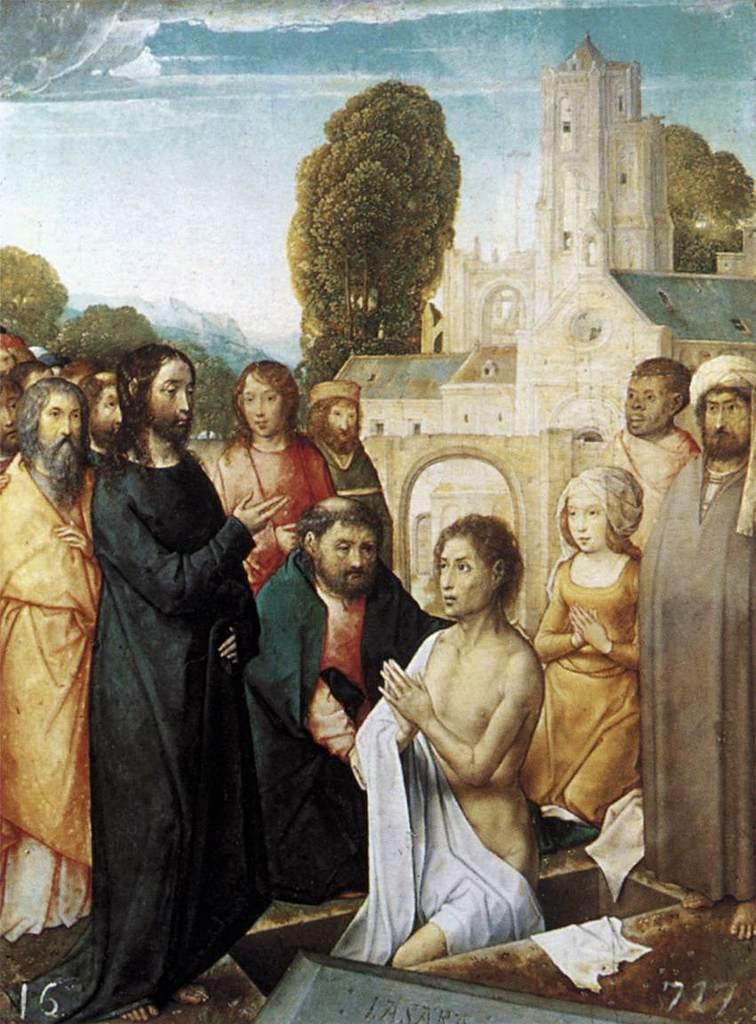What is the main subject of the image? There is a painting in the image. Are there any other elements in the image besides the painting? Yes, there is a group of people, a building, trees, and the sky visible in the image. Can you describe the setting of the image? The image features a painting, a group of people, a building, trees, and the sky, suggesting an outdoor scene. What type of tin can be seen in the image? There is no tin present in the image. How many matches are being used by the group of people in the image? There are no matches visible in the image; it features a painting, a group of people, a building, trees, and the sky. 